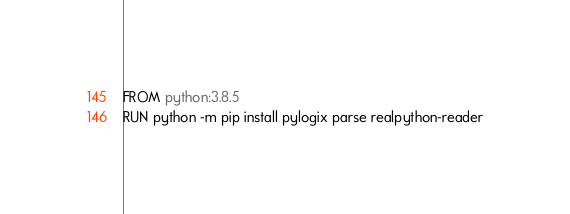<code> <loc_0><loc_0><loc_500><loc_500><_Dockerfile_>FROM python:3.8.5
RUN python -m pip install pylogix parse realpython-reader</code> 